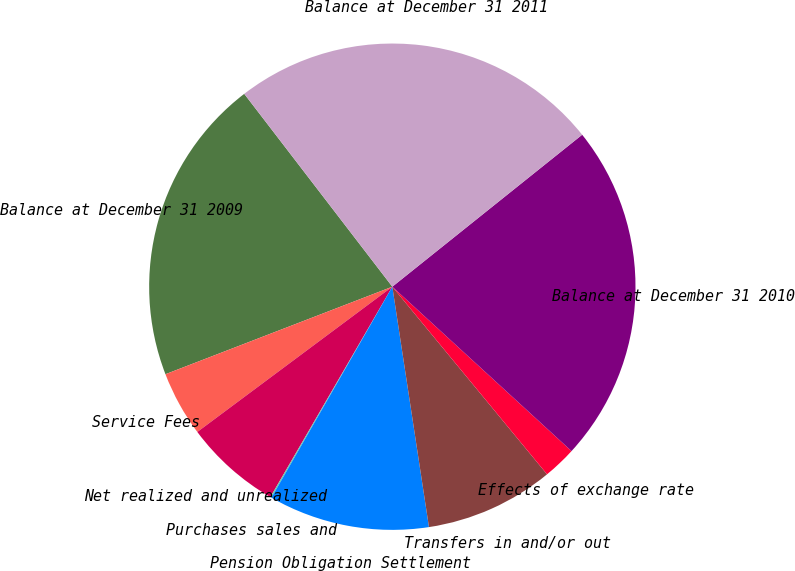Convert chart. <chart><loc_0><loc_0><loc_500><loc_500><pie_chart><fcel>Balance at December 31 2009<fcel>Service Fees<fcel>Net realized and unrealized<fcel>Purchases sales and<fcel>Pension Obligation Settlement<fcel>Transfers in and/or out<fcel>Effects of exchange rate<fcel>Balance at December 31 2010<fcel>Balance at December 31 2011<nl><fcel>20.44%<fcel>4.33%<fcel>6.45%<fcel>0.08%<fcel>10.69%<fcel>8.57%<fcel>2.21%<fcel>22.56%<fcel>24.68%<nl></chart> 